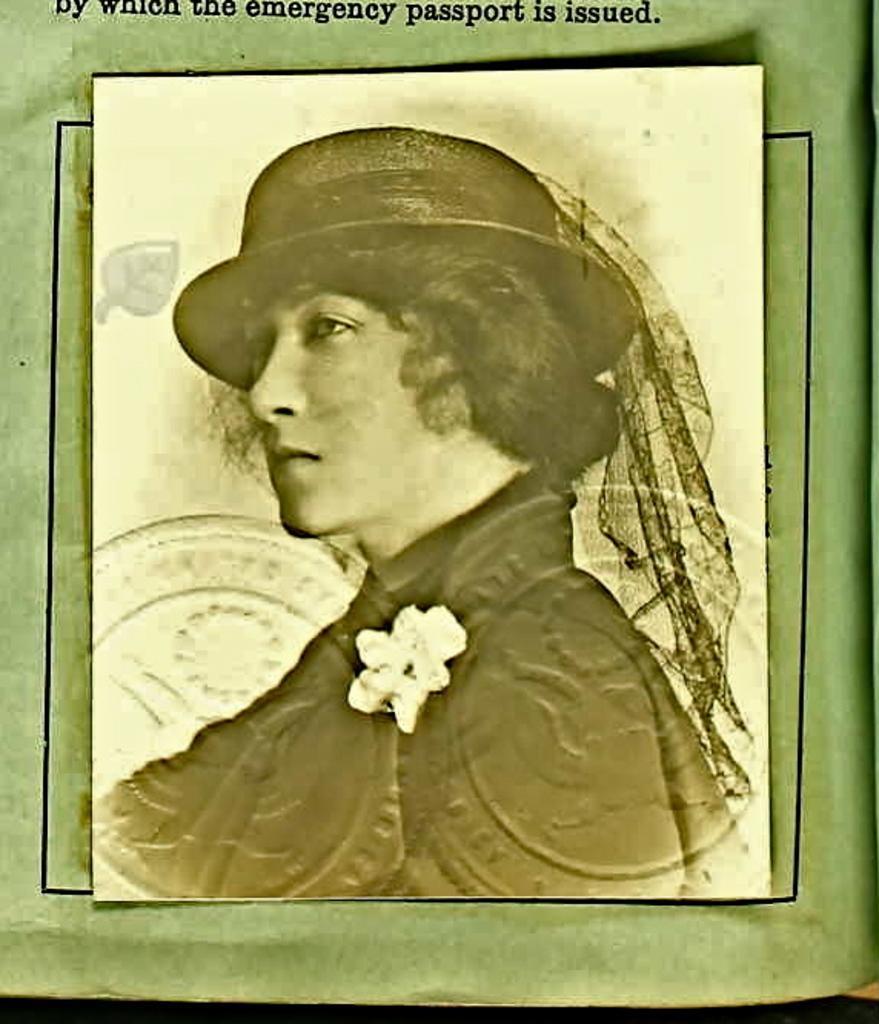In one or two sentences, can you explain what this image depicts? In this picture there is a poster which is pasted in a book. In the center I can see the image of a woman. At the bottom of the photo I can see two stamps on it. At the top there is a watermark. 